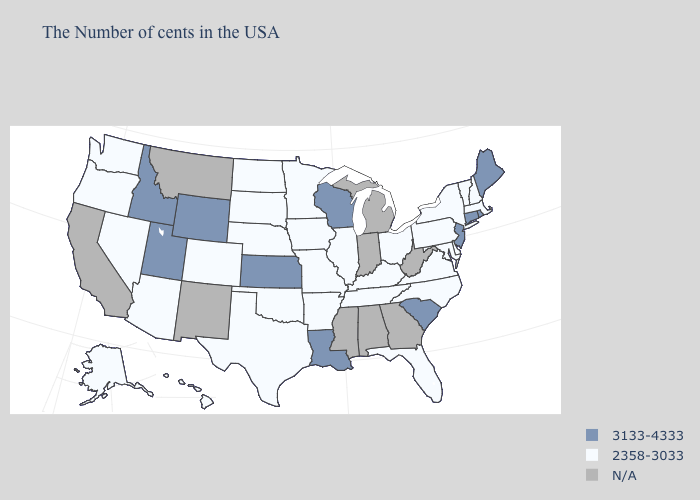Which states hav the highest value in the MidWest?
Keep it brief. Wisconsin, Kansas. Name the states that have a value in the range 2358-3033?
Keep it brief. Massachusetts, New Hampshire, Vermont, New York, Delaware, Maryland, Pennsylvania, Virginia, North Carolina, Ohio, Florida, Kentucky, Tennessee, Illinois, Missouri, Arkansas, Minnesota, Iowa, Nebraska, Oklahoma, Texas, South Dakota, North Dakota, Colorado, Arizona, Nevada, Washington, Oregon, Alaska, Hawaii. Does the map have missing data?
Short answer required. Yes. What is the highest value in states that border South Dakota?
Short answer required. 3133-4333. What is the lowest value in the USA?
Answer briefly. 2358-3033. Name the states that have a value in the range N/A?
Answer briefly. West Virginia, Georgia, Michigan, Indiana, Alabama, Mississippi, New Mexico, Montana, California. What is the value of Maryland?
Answer briefly. 2358-3033. What is the value of Wyoming?
Concise answer only. 3133-4333. Name the states that have a value in the range 2358-3033?
Quick response, please. Massachusetts, New Hampshire, Vermont, New York, Delaware, Maryland, Pennsylvania, Virginia, North Carolina, Ohio, Florida, Kentucky, Tennessee, Illinois, Missouri, Arkansas, Minnesota, Iowa, Nebraska, Oklahoma, Texas, South Dakota, North Dakota, Colorado, Arizona, Nevada, Washington, Oregon, Alaska, Hawaii. Name the states that have a value in the range 2358-3033?
Concise answer only. Massachusetts, New Hampshire, Vermont, New York, Delaware, Maryland, Pennsylvania, Virginia, North Carolina, Ohio, Florida, Kentucky, Tennessee, Illinois, Missouri, Arkansas, Minnesota, Iowa, Nebraska, Oklahoma, Texas, South Dakota, North Dakota, Colorado, Arizona, Nevada, Washington, Oregon, Alaska, Hawaii. Which states hav the highest value in the MidWest?
Quick response, please. Wisconsin, Kansas. What is the highest value in states that border Arkansas?
Answer briefly. 3133-4333. What is the value of Arkansas?
Quick response, please. 2358-3033. 